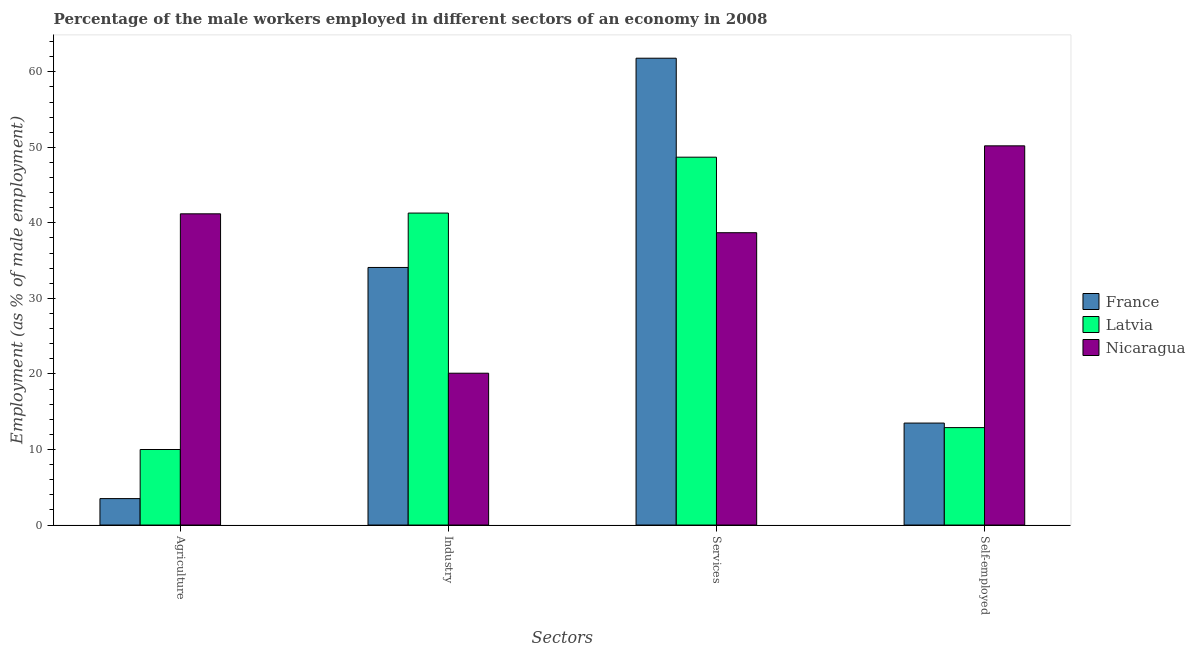How many groups of bars are there?
Offer a terse response. 4. Are the number of bars on each tick of the X-axis equal?
Offer a terse response. Yes. How many bars are there on the 2nd tick from the left?
Give a very brief answer. 3. How many bars are there on the 3rd tick from the right?
Ensure brevity in your answer.  3. What is the label of the 1st group of bars from the left?
Give a very brief answer. Agriculture. What is the percentage of male workers in services in France?
Your answer should be compact. 61.8. Across all countries, what is the maximum percentage of male workers in services?
Give a very brief answer. 61.8. Across all countries, what is the minimum percentage of male workers in services?
Provide a short and direct response. 38.7. In which country was the percentage of self employed male workers maximum?
Give a very brief answer. Nicaragua. In which country was the percentage of male workers in services minimum?
Keep it short and to the point. Nicaragua. What is the total percentage of self employed male workers in the graph?
Make the answer very short. 76.6. What is the difference between the percentage of male workers in agriculture in Nicaragua and that in France?
Provide a succinct answer. 37.7. What is the difference between the percentage of male workers in industry in Latvia and the percentage of male workers in agriculture in France?
Your answer should be very brief. 37.8. What is the average percentage of male workers in industry per country?
Make the answer very short. 31.83. What is the difference between the percentage of self employed male workers and percentage of male workers in industry in France?
Provide a short and direct response. -20.6. What is the ratio of the percentage of male workers in agriculture in Nicaragua to that in France?
Your answer should be compact. 11.77. Is the percentage of male workers in services in Latvia less than that in Nicaragua?
Give a very brief answer. No. What is the difference between the highest and the second highest percentage of male workers in agriculture?
Offer a terse response. 31.2. What is the difference between the highest and the lowest percentage of male workers in industry?
Your answer should be compact. 21.2. Is the sum of the percentage of male workers in agriculture in France and Latvia greater than the maximum percentage of male workers in industry across all countries?
Provide a succinct answer. No. Is it the case that in every country, the sum of the percentage of male workers in agriculture and percentage of male workers in services is greater than the sum of percentage of self employed male workers and percentage of male workers in industry?
Your answer should be very brief. Yes. What does the 2nd bar from the left in Agriculture represents?
Your answer should be very brief. Latvia. What does the 1st bar from the right in Self-employed represents?
Make the answer very short. Nicaragua. Is it the case that in every country, the sum of the percentage of male workers in agriculture and percentage of male workers in industry is greater than the percentage of male workers in services?
Your answer should be very brief. No. Are all the bars in the graph horizontal?
Offer a terse response. No. How many countries are there in the graph?
Offer a terse response. 3. Does the graph contain any zero values?
Provide a short and direct response. No. Does the graph contain grids?
Offer a terse response. No. How many legend labels are there?
Provide a short and direct response. 3. What is the title of the graph?
Your answer should be compact. Percentage of the male workers employed in different sectors of an economy in 2008. Does "Equatorial Guinea" appear as one of the legend labels in the graph?
Your answer should be very brief. No. What is the label or title of the X-axis?
Give a very brief answer. Sectors. What is the label or title of the Y-axis?
Ensure brevity in your answer.  Employment (as % of male employment). What is the Employment (as % of male employment) in Latvia in Agriculture?
Keep it short and to the point. 10. What is the Employment (as % of male employment) in Nicaragua in Agriculture?
Give a very brief answer. 41.2. What is the Employment (as % of male employment) of France in Industry?
Ensure brevity in your answer.  34.1. What is the Employment (as % of male employment) in Latvia in Industry?
Offer a very short reply. 41.3. What is the Employment (as % of male employment) in Nicaragua in Industry?
Provide a succinct answer. 20.1. What is the Employment (as % of male employment) of France in Services?
Ensure brevity in your answer.  61.8. What is the Employment (as % of male employment) in Latvia in Services?
Provide a short and direct response. 48.7. What is the Employment (as % of male employment) of Nicaragua in Services?
Offer a very short reply. 38.7. What is the Employment (as % of male employment) of France in Self-employed?
Provide a succinct answer. 13.5. What is the Employment (as % of male employment) in Latvia in Self-employed?
Offer a terse response. 12.9. What is the Employment (as % of male employment) in Nicaragua in Self-employed?
Provide a succinct answer. 50.2. Across all Sectors, what is the maximum Employment (as % of male employment) in France?
Keep it short and to the point. 61.8. Across all Sectors, what is the maximum Employment (as % of male employment) of Latvia?
Ensure brevity in your answer.  48.7. Across all Sectors, what is the maximum Employment (as % of male employment) of Nicaragua?
Ensure brevity in your answer.  50.2. Across all Sectors, what is the minimum Employment (as % of male employment) in France?
Offer a very short reply. 3.5. Across all Sectors, what is the minimum Employment (as % of male employment) of Nicaragua?
Provide a succinct answer. 20.1. What is the total Employment (as % of male employment) of France in the graph?
Provide a succinct answer. 112.9. What is the total Employment (as % of male employment) in Latvia in the graph?
Offer a terse response. 112.9. What is the total Employment (as % of male employment) in Nicaragua in the graph?
Make the answer very short. 150.2. What is the difference between the Employment (as % of male employment) of France in Agriculture and that in Industry?
Provide a succinct answer. -30.6. What is the difference between the Employment (as % of male employment) in Latvia in Agriculture and that in Industry?
Your answer should be compact. -31.3. What is the difference between the Employment (as % of male employment) in Nicaragua in Agriculture and that in Industry?
Your response must be concise. 21.1. What is the difference between the Employment (as % of male employment) of France in Agriculture and that in Services?
Offer a very short reply. -58.3. What is the difference between the Employment (as % of male employment) of Latvia in Agriculture and that in Services?
Your response must be concise. -38.7. What is the difference between the Employment (as % of male employment) of Nicaragua in Agriculture and that in Self-employed?
Offer a very short reply. -9. What is the difference between the Employment (as % of male employment) of France in Industry and that in Services?
Provide a short and direct response. -27.7. What is the difference between the Employment (as % of male employment) in Latvia in Industry and that in Services?
Provide a short and direct response. -7.4. What is the difference between the Employment (as % of male employment) in Nicaragua in Industry and that in Services?
Your answer should be compact. -18.6. What is the difference between the Employment (as % of male employment) of France in Industry and that in Self-employed?
Provide a short and direct response. 20.6. What is the difference between the Employment (as % of male employment) in Latvia in Industry and that in Self-employed?
Keep it short and to the point. 28.4. What is the difference between the Employment (as % of male employment) in Nicaragua in Industry and that in Self-employed?
Ensure brevity in your answer.  -30.1. What is the difference between the Employment (as % of male employment) of France in Services and that in Self-employed?
Offer a very short reply. 48.3. What is the difference between the Employment (as % of male employment) in Latvia in Services and that in Self-employed?
Ensure brevity in your answer.  35.8. What is the difference between the Employment (as % of male employment) in Nicaragua in Services and that in Self-employed?
Provide a succinct answer. -11.5. What is the difference between the Employment (as % of male employment) in France in Agriculture and the Employment (as % of male employment) in Latvia in Industry?
Your answer should be very brief. -37.8. What is the difference between the Employment (as % of male employment) of France in Agriculture and the Employment (as % of male employment) of Nicaragua in Industry?
Offer a terse response. -16.6. What is the difference between the Employment (as % of male employment) of Latvia in Agriculture and the Employment (as % of male employment) of Nicaragua in Industry?
Make the answer very short. -10.1. What is the difference between the Employment (as % of male employment) of France in Agriculture and the Employment (as % of male employment) of Latvia in Services?
Provide a short and direct response. -45.2. What is the difference between the Employment (as % of male employment) of France in Agriculture and the Employment (as % of male employment) of Nicaragua in Services?
Your answer should be very brief. -35.2. What is the difference between the Employment (as % of male employment) of Latvia in Agriculture and the Employment (as % of male employment) of Nicaragua in Services?
Give a very brief answer. -28.7. What is the difference between the Employment (as % of male employment) of France in Agriculture and the Employment (as % of male employment) of Latvia in Self-employed?
Make the answer very short. -9.4. What is the difference between the Employment (as % of male employment) of France in Agriculture and the Employment (as % of male employment) of Nicaragua in Self-employed?
Provide a short and direct response. -46.7. What is the difference between the Employment (as % of male employment) of Latvia in Agriculture and the Employment (as % of male employment) of Nicaragua in Self-employed?
Your answer should be very brief. -40.2. What is the difference between the Employment (as % of male employment) in France in Industry and the Employment (as % of male employment) in Latvia in Services?
Offer a terse response. -14.6. What is the difference between the Employment (as % of male employment) in Latvia in Industry and the Employment (as % of male employment) in Nicaragua in Services?
Ensure brevity in your answer.  2.6. What is the difference between the Employment (as % of male employment) in France in Industry and the Employment (as % of male employment) in Latvia in Self-employed?
Keep it short and to the point. 21.2. What is the difference between the Employment (as % of male employment) of France in Industry and the Employment (as % of male employment) of Nicaragua in Self-employed?
Your answer should be very brief. -16.1. What is the difference between the Employment (as % of male employment) in Latvia in Industry and the Employment (as % of male employment) in Nicaragua in Self-employed?
Keep it short and to the point. -8.9. What is the difference between the Employment (as % of male employment) in France in Services and the Employment (as % of male employment) in Latvia in Self-employed?
Offer a very short reply. 48.9. What is the difference between the Employment (as % of male employment) in Latvia in Services and the Employment (as % of male employment) in Nicaragua in Self-employed?
Provide a succinct answer. -1.5. What is the average Employment (as % of male employment) of France per Sectors?
Your answer should be very brief. 28.23. What is the average Employment (as % of male employment) of Latvia per Sectors?
Your answer should be very brief. 28.23. What is the average Employment (as % of male employment) in Nicaragua per Sectors?
Provide a succinct answer. 37.55. What is the difference between the Employment (as % of male employment) in France and Employment (as % of male employment) in Latvia in Agriculture?
Your response must be concise. -6.5. What is the difference between the Employment (as % of male employment) in France and Employment (as % of male employment) in Nicaragua in Agriculture?
Provide a short and direct response. -37.7. What is the difference between the Employment (as % of male employment) of Latvia and Employment (as % of male employment) of Nicaragua in Agriculture?
Your answer should be compact. -31.2. What is the difference between the Employment (as % of male employment) of Latvia and Employment (as % of male employment) of Nicaragua in Industry?
Give a very brief answer. 21.2. What is the difference between the Employment (as % of male employment) in France and Employment (as % of male employment) in Latvia in Services?
Your answer should be compact. 13.1. What is the difference between the Employment (as % of male employment) in France and Employment (as % of male employment) in Nicaragua in Services?
Give a very brief answer. 23.1. What is the difference between the Employment (as % of male employment) of Latvia and Employment (as % of male employment) of Nicaragua in Services?
Provide a short and direct response. 10. What is the difference between the Employment (as % of male employment) in France and Employment (as % of male employment) in Nicaragua in Self-employed?
Your answer should be very brief. -36.7. What is the difference between the Employment (as % of male employment) of Latvia and Employment (as % of male employment) of Nicaragua in Self-employed?
Offer a terse response. -37.3. What is the ratio of the Employment (as % of male employment) of France in Agriculture to that in Industry?
Your answer should be very brief. 0.1. What is the ratio of the Employment (as % of male employment) of Latvia in Agriculture to that in Industry?
Ensure brevity in your answer.  0.24. What is the ratio of the Employment (as % of male employment) in Nicaragua in Agriculture to that in Industry?
Offer a terse response. 2.05. What is the ratio of the Employment (as % of male employment) of France in Agriculture to that in Services?
Give a very brief answer. 0.06. What is the ratio of the Employment (as % of male employment) in Latvia in Agriculture to that in Services?
Your answer should be compact. 0.21. What is the ratio of the Employment (as % of male employment) in Nicaragua in Agriculture to that in Services?
Provide a succinct answer. 1.06. What is the ratio of the Employment (as % of male employment) of France in Agriculture to that in Self-employed?
Give a very brief answer. 0.26. What is the ratio of the Employment (as % of male employment) of Latvia in Agriculture to that in Self-employed?
Ensure brevity in your answer.  0.78. What is the ratio of the Employment (as % of male employment) in Nicaragua in Agriculture to that in Self-employed?
Provide a succinct answer. 0.82. What is the ratio of the Employment (as % of male employment) of France in Industry to that in Services?
Give a very brief answer. 0.55. What is the ratio of the Employment (as % of male employment) of Latvia in Industry to that in Services?
Make the answer very short. 0.85. What is the ratio of the Employment (as % of male employment) of Nicaragua in Industry to that in Services?
Provide a short and direct response. 0.52. What is the ratio of the Employment (as % of male employment) in France in Industry to that in Self-employed?
Offer a terse response. 2.53. What is the ratio of the Employment (as % of male employment) of Latvia in Industry to that in Self-employed?
Your answer should be very brief. 3.2. What is the ratio of the Employment (as % of male employment) in Nicaragua in Industry to that in Self-employed?
Offer a terse response. 0.4. What is the ratio of the Employment (as % of male employment) of France in Services to that in Self-employed?
Keep it short and to the point. 4.58. What is the ratio of the Employment (as % of male employment) of Latvia in Services to that in Self-employed?
Provide a succinct answer. 3.78. What is the ratio of the Employment (as % of male employment) in Nicaragua in Services to that in Self-employed?
Provide a short and direct response. 0.77. What is the difference between the highest and the second highest Employment (as % of male employment) of France?
Offer a very short reply. 27.7. What is the difference between the highest and the lowest Employment (as % of male employment) in France?
Your response must be concise. 58.3. What is the difference between the highest and the lowest Employment (as % of male employment) of Latvia?
Offer a terse response. 38.7. What is the difference between the highest and the lowest Employment (as % of male employment) in Nicaragua?
Offer a very short reply. 30.1. 